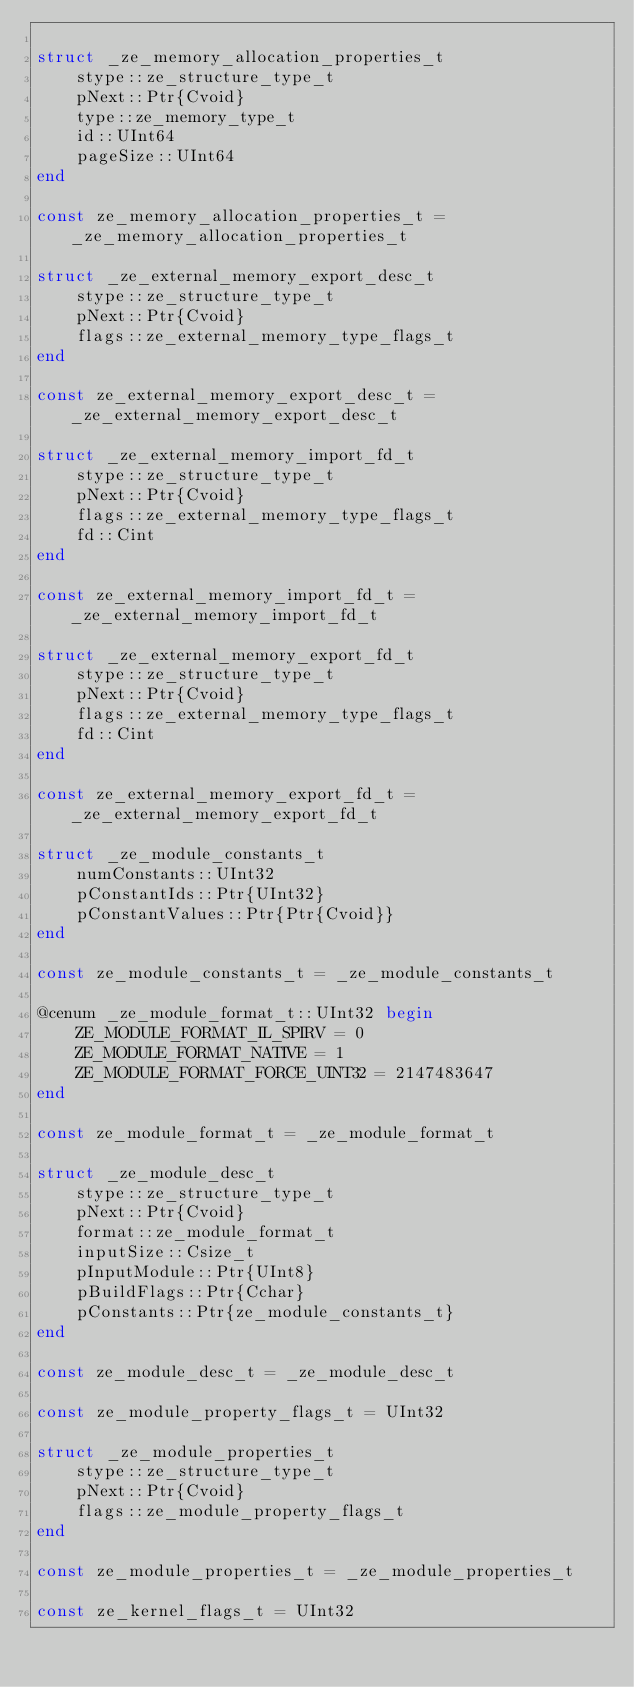Convert code to text. <code><loc_0><loc_0><loc_500><loc_500><_Julia_>
struct _ze_memory_allocation_properties_t
    stype::ze_structure_type_t
    pNext::Ptr{Cvoid}
    type::ze_memory_type_t
    id::UInt64
    pageSize::UInt64
end

const ze_memory_allocation_properties_t = _ze_memory_allocation_properties_t

struct _ze_external_memory_export_desc_t
    stype::ze_structure_type_t
    pNext::Ptr{Cvoid}
    flags::ze_external_memory_type_flags_t
end

const ze_external_memory_export_desc_t = _ze_external_memory_export_desc_t

struct _ze_external_memory_import_fd_t
    stype::ze_structure_type_t
    pNext::Ptr{Cvoid}
    flags::ze_external_memory_type_flags_t
    fd::Cint
end

const ze_external_memory_import_fd_t = _ze_external_memory_import_fd_t

struct _ze_external_memory_export_fd_t
    stype::ze_structure_type_t
    pNext::Ptr{Cvoid}
    flags::ze_external_memory_type_flags_t
    fd::Cint
end

const ze_external_memory_export_fd_t = _ze_external_memory_export_fd_t

struct _ze_module_constants_t
    numConstants::UInt32
    pConstantIds::Ptr{UInt32}
    pConstantValues::Ptr{Ptr{Cvoid}}
end

const ze_module_constants_t = _ze_module_constants_t

@cenum _ze_module_format_t::UInt32 begin
    ZE_MODULE_FORMAT_IL_SPIRV = 0
    ZE_MODULE_FORMAT_NATIVE = 1
    ZE_MODULE_FORMAT_FORCE_UINT32 = 2147483647
end

const ze_module_format_t = _ze_module_format_t

struct _ze_module_desc_t
    stype::ze_structure_type_t
    pNext::Ptr{Cvoid}
    format::ze_module_format_t
    inputSize::Csize_t
    pInputModule::Ptr{UInt8}
    pBuildFlags::Ptr{Cchar}
    pConstants::Ptr{ze_module_constants_t}
end

const ze_module_desc_t = _ze_module_desc_t

const ze_module_property_flags_t = UInt32

struct _ze_module_properties_t
    stype::ze_structure_type_t
    pNext::Ptr{Cvoid}
    flags::ze_module_property_flags_t
end

const ze_module_properties_t = _ze_module_properties_t

const ze_kernel_flags_t = UInt32
</code> 